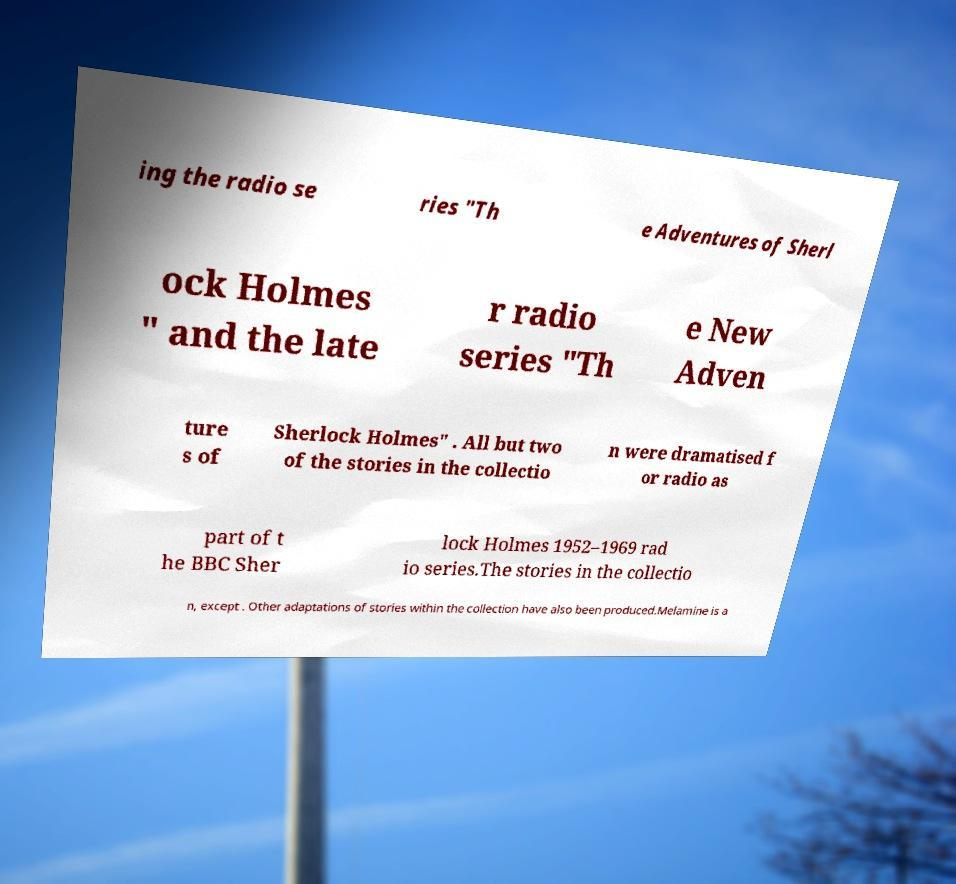For documentation purposes, I need the text within this image transcribed. Could you provide that? ing the radio se ries "Th e Adventures of Sherl ock Holmes " and the late r radio series "Th e New Adven ture s of Sherlock Holmes" . All but two of the stories in the collectio n were dramatised f or radio as part of t he BBC Sher lock Holmes 1952–1969 rad io series.The stories in the collectio n, except . Other adaptations of stories within the collection have also been produced.Melamine is a 